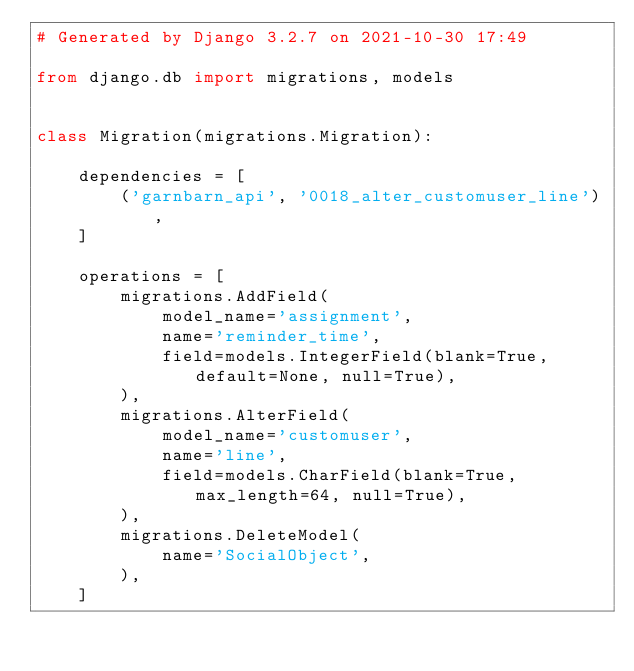<code> <loc_0><loc_0><loc_500><loc_500><_Python_># Generated by Django 3.2.7 on 2021-10-30 17:49

from django.db import migrations, models


class Migration(migrations.Migration):

    dependencies = [
        ('garnbarn_api', '0018_alter_customuser_line'),
    ]

    operations = [
        migrations.AddField(
            model_name='assignment',
            name='reminder_time',
            field=models.IntegerField(blank=True, default=None, null=True),
        ),
        migrations.AlterField(
            model_name='customuser',
            name='line',
            field=models.CharField(blank=True, max_length=64, null=True),
        ),
        migrations.DeleteModel(
            name='SocialObject',
        ),
    ]
</code> 